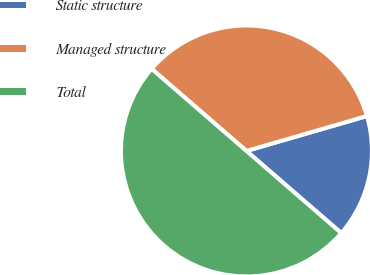Convert chart to OTSL. <chart><loc_0><loc_0><loc_500><loc_500><pie_chart><fcel>Static structure<fcel>Managed structure<fcel>Total<nl><fcel>15.85%<fcel>34.15%<fcel>50.0%<nl></chart> 